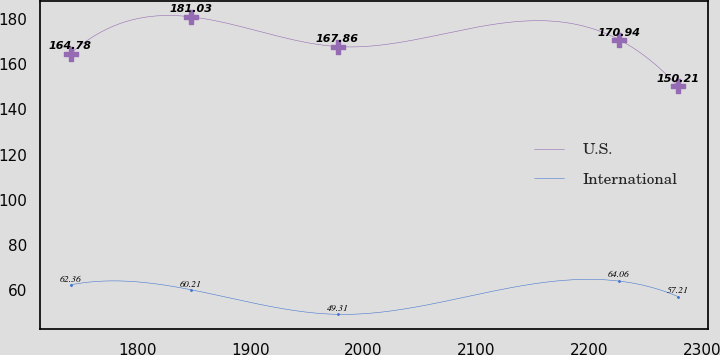<chart> <loc_0><loc_0><loc_500><loc_500><line_chart><ecel><fcel>U.S.<fcel>International<nl><fcel>1740.49<fcel>164.78<fcel>62.36<nl><fcel>1847.14<fcel>181.03<fcel>60.21<nl><fcel>1976.94<fcel>167.86<fcel>49.31<nl><fcel>2226.14<fcel>170.94<fcel>64.06<nl><fcel>2278.37<fcel>150.21<fcel>57.21<nl></chart> 